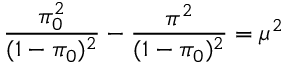Convert formula to latex. <formula><loc_0><loc_0><loc_500><loc_500>\frac { \pi _ { 0 } ^ { 2 } } { ( 1 - \pi _ { 0 } ) ^ { 2 } } - \frac { \pi ^ { 2 } } { ( 1 - \pi _ { 0 } ) ^ { 2 } } = \mu ^ { 2 }</formula> 